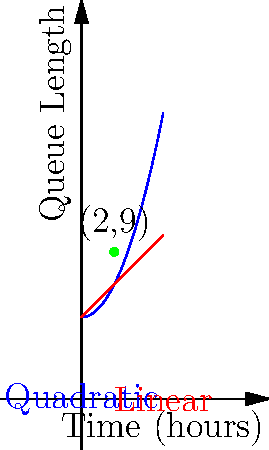As a food truck owner, you notice that during peak hours at a block party, your customer queue length changes over time. The graph shows two models of queue length: a quadratic model (blue) and a linear model (red). At the 2-hour mark, both models intersect at the point (2,9). If the quadratic model accurately represents your queue length, what is the instantaneous rate of change of the queue length at the 2-hour mark? To find the instantaneous rate of change at the 2-hour mark, we need to calculate the derivative of the quadratic function at x = 2.

Step 1: Identify the quadratic function.
The general form of a quadratic function is $f(x) = ax^2 + bx + c$.
From the given information, we know that $f(2) = 9$ and $f(0) = 5$.

Step 2: Determine the quadratic function.
$f(x) = 0.5x^2 + 5$ (This can be derived from the given information)

Step 3: Calculate the derivative of the quadratic function.
$f'(x) = \frac{d}{dx}(0.5x^2 + 5) = x$

Step 4: Evaluate the derivative at x = 2.
$f'(2) = 2$

Therefore, the instantaneous rate of change of the queue length at the 2-hour mark is 2 customers per hour.
Answer: 2 customers/hour 